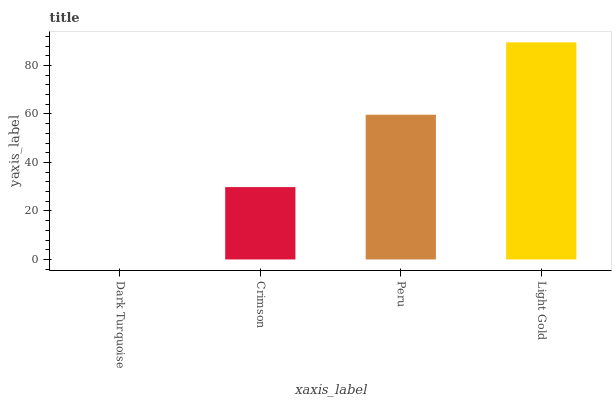Is Dark Turquoise the minimum?
Answer yes or no. Yes. Is Light Gold the maximum?
Answer yes or no. Yes. Is Crimson the minimum?
Answer yes or no. No. Is Crimson the maximum?
Answer yes or no. No. Is Crimson greater than Dark Turquoise?
Answer yes or no. Yes. Is Dark Turquoise less than Crimson?
Answer yes or no. Yes. Is Dark Turquoise greater than Crimson?
Answer yes or no. No. Is Crimson less than Dark Turquoise?
Answer yes or no. No. Is Peru the high median?
Answer yes or no. Yes. Is Crimson the low median?
Answer yes or no. Yes. Is Light Gold the high median?
Answer yes or no. No. Is Peru the low median?
Answer yes or no. No. 